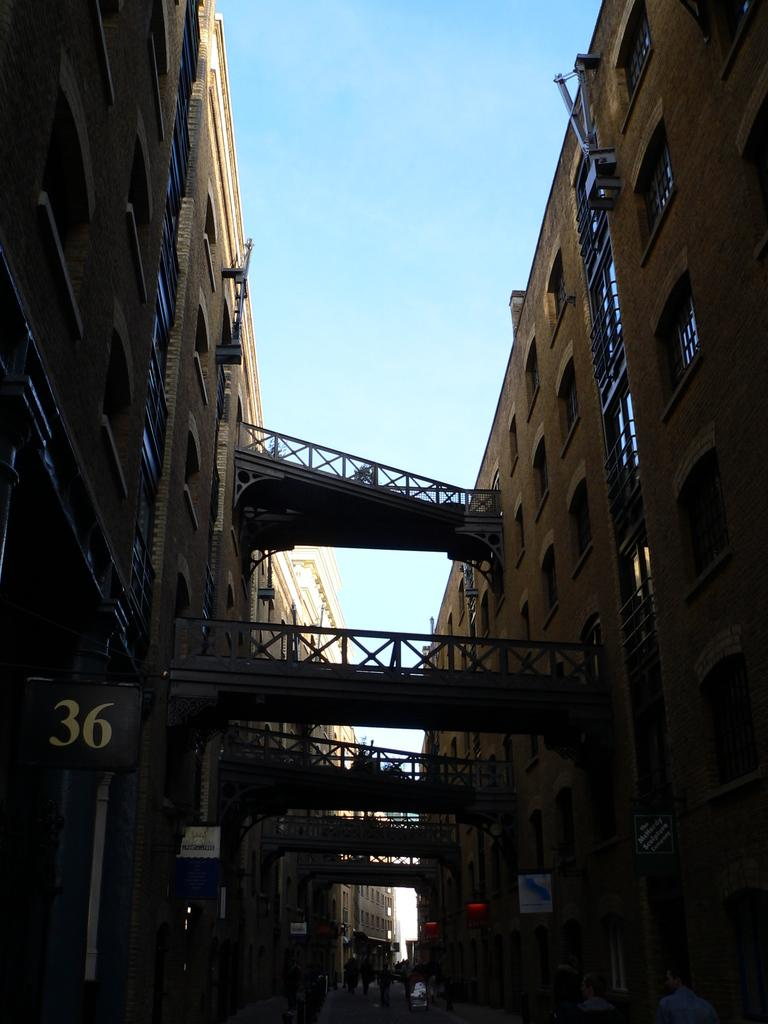What type of structures can be seen in the image? There are buildings, railings, and bridges in the image. What else is present in the image besides structures? There are people, boards, and unspecified objects in the image. What can be seen in the background of the image? The sky is visible in the image. What color is the ink used by the father in the image? There is no father or ink present in the image. What type of operation is being performed on the unspecified objects in the image? There is no operation being performed on the unspecified objects in the image. 